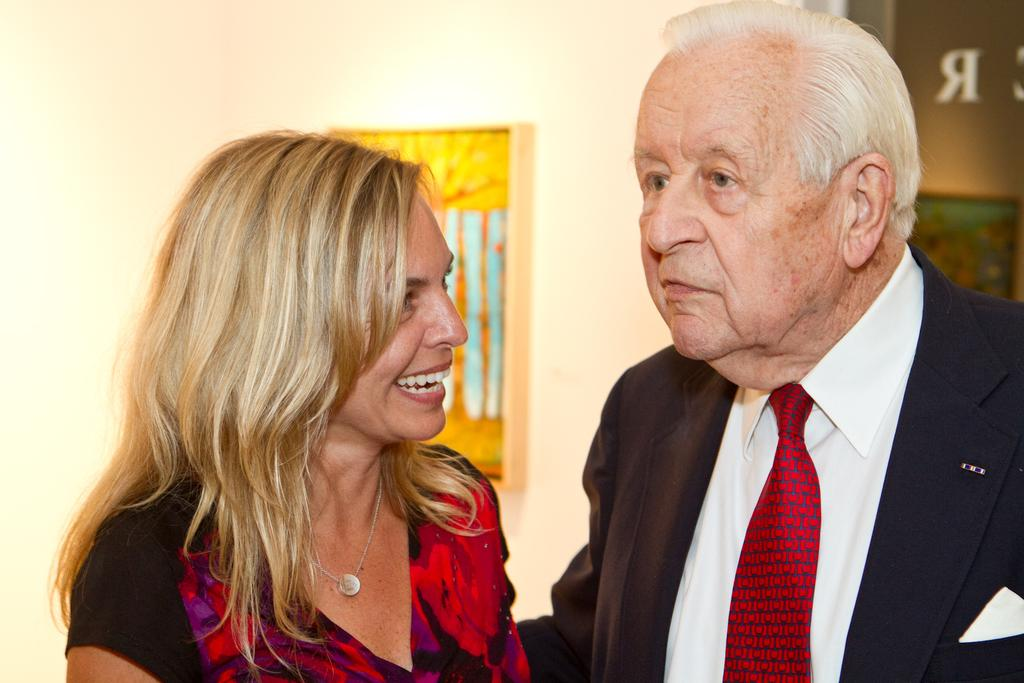How many people are in the image? There are two persons in the image. What is the man wearing in the image? The man is wearing a suit and a tie. What can be seen on the wall in the background of the image? There is a frame on the wall in the background. What type of accessory is the woman wearing in the image? The woman is wearing a necklace. How many children are playing with the squirrel in the image? There are no children or squirrels present in the image. What type of music is being played in the background of the image? There is no music being played in the image; it is a still photograph. 